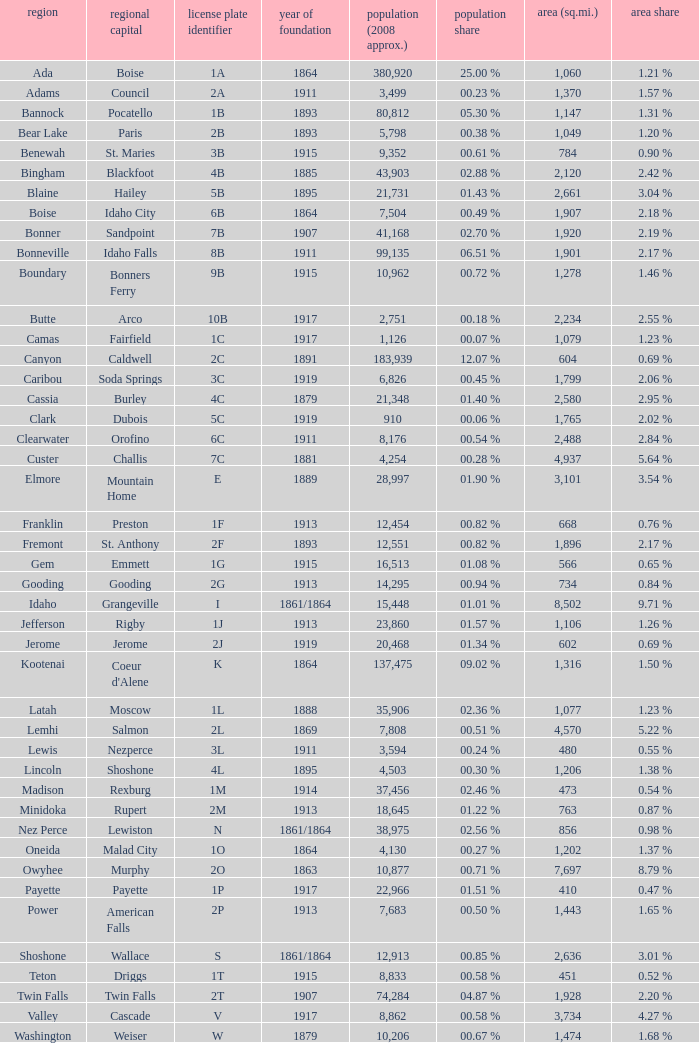What is the license plate code for the country with an area of 784? 3B. 